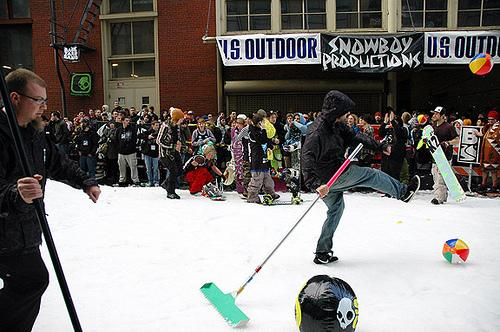Provide a brief description of the man present in the image. The man is wearing glasses, an orange hat, a black jacket, red pants, and has his hood up. He is also kicking his leg up and holding a shovel. What does the ground look like in the image? The ground is covered in white snow, providing a contrast to the colorful beach balls and the people. Describe the clothing and accessories the man in the image is wearing. The man is wearing a black jacket, red pants, glasses, and an orange hat, with his hood up. What are the two signs present and what colors does each have? The two signs are a black sign with white letters and a green and black skull sign. Describe the scene in the image that involves a beach ball. A colorful beach ball is in the air, while another one lies on the snow-covered ground, surrounded by a crowd of people watching. What are the main objects in the image? The main objects include beach balls, a black ball with white skulls, a shovel, a crowd of people, a building with an emergency ladder, and a man wearing various clothing items. How many beach balls are there in the image, and describe their appearance. There are two beach balls; one is colorful and in the sky, and the other is on the snow with many different colors. 